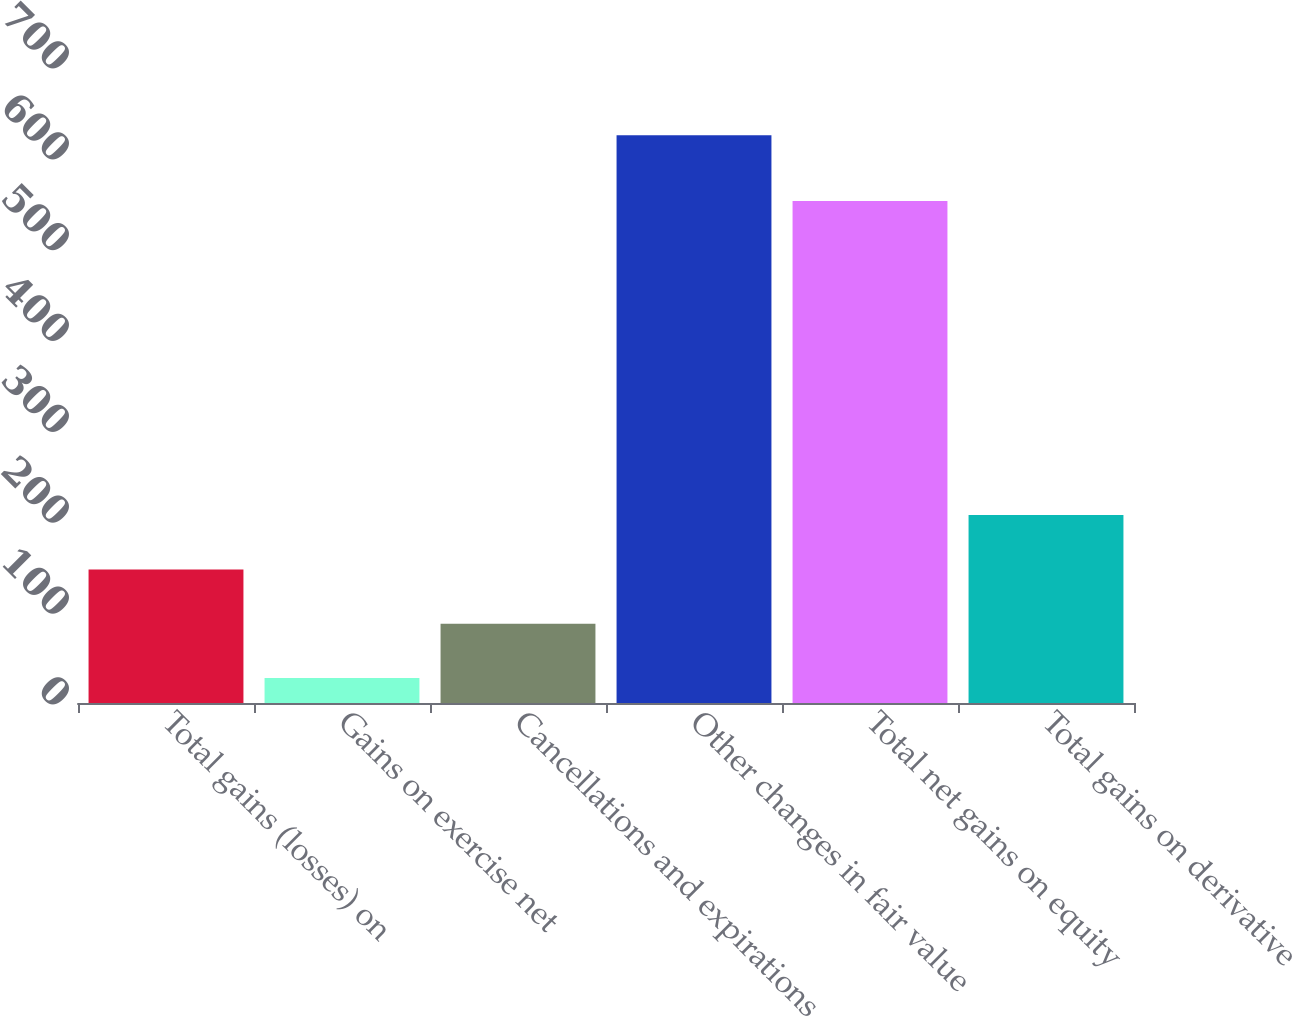Convert chart to OTSL. <chart><loc_0><loc_0><loc_500><loc_500><bar_chart><fcel>Total gains (losses) on<fcel>Gains on exercise net<fcel>Cancellations and expirations<fcel>Other changes in fair value<fcel>Total net gains on equity<fcel>Total gains on derivative<nl><fcel>147.06<fcel>27.6<fcel>87.33<fcel>624.9<fcel>552.6<fcel>206.79<nl></chart> 